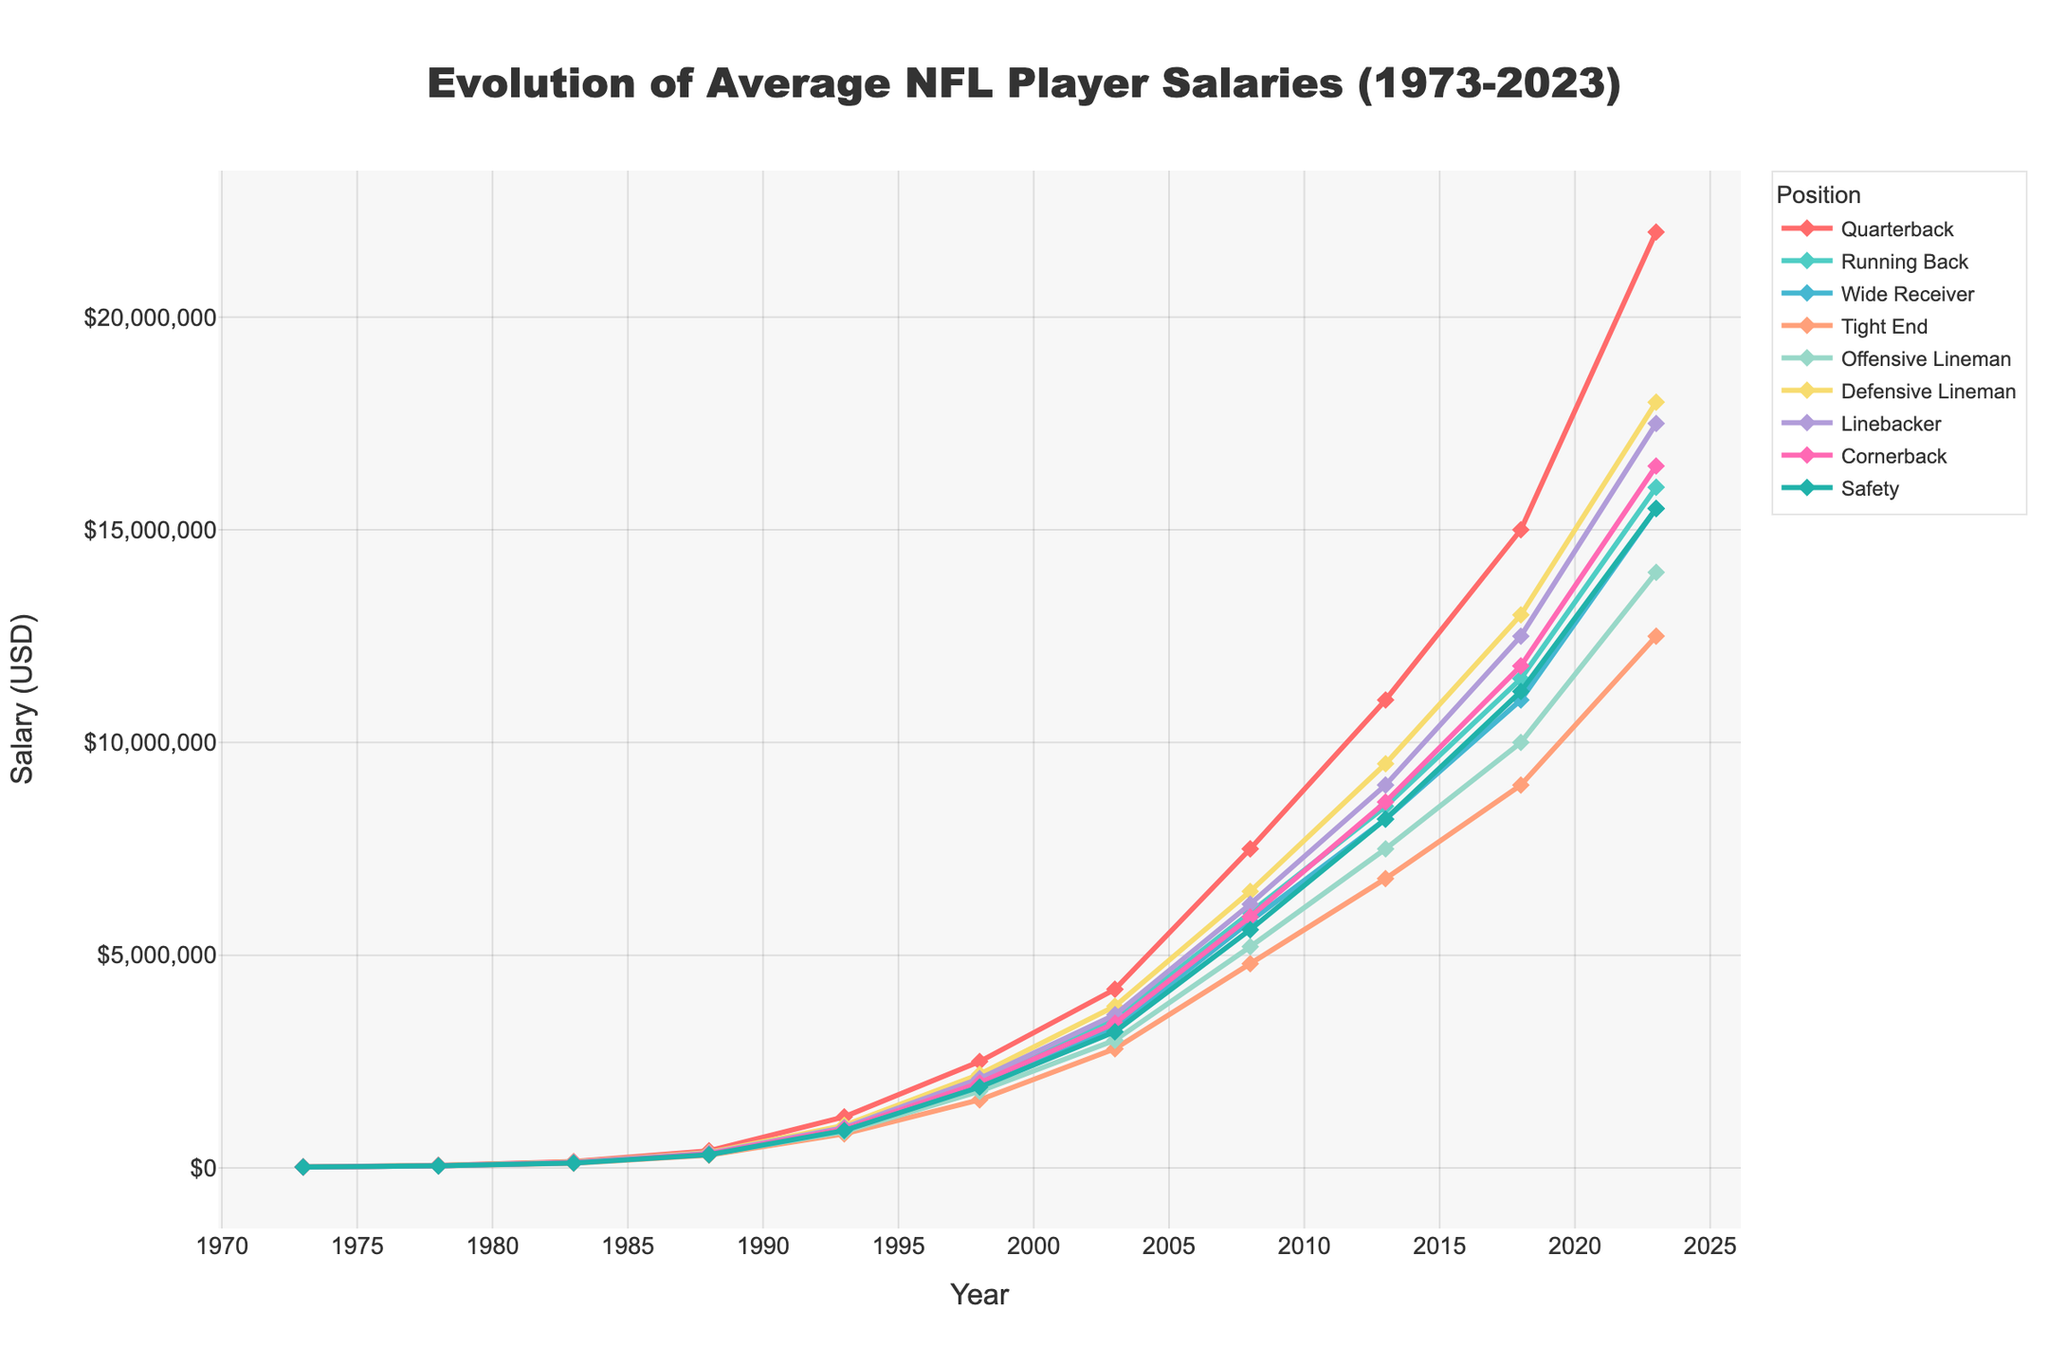Which position had the highest average salary in 2023? To determine this, look at the endpoints of the lines on the far right side of the chart. The line that reaches the highest vertical point represents the highest average salary.
Answer: Quarterback How much did the average salary of a Linebacker increase from 1983 to 2023? Locate the points for Linebackers in 1983 and 2023. Subtract the 1983 salary (128,000) from the 2023 salary (17,500,000).
Answer: 17,372,000 Which position saw the least salary increase over the entire period from 1973 to 2023? Compare the starting and ending points of all the lines. The position with the smallest difference between 1973 and 2023 has the least increase.
Answer: Tight End Among the positions, which one had a higher average salary in 1998: Wide Receiver or Tight End? Check and compare the heights of the points of Wide Receiver and Tight End in 1998.
Answer: Wide Receiver What was the trend in average salaries for Running Backs from 1973 to 2023? Observe the line for Running Backs from left to right. Note how the line rises steadily, indicating a consistent increase over the years.
Answer: Increasing Compare the salaries of Defensive Linemen and Offensive Linemen in 2008. Which one was higher and by how much? Locate the points for both positions in 2008 on the y-axis. Subtract the value for Offensive Linemen (5,200,000) from Defensive Linemen (6,500,000).
Answer: Defensive Linemen by 1,300,000 What is the average salary of a Safety in 1983 and 2003 combined? Add the salaries for Safeties in 1983 (115,000) and 2003 (3,200,000) and divide the sum by 2.
Answer: 1,657,500 Which position had the most significant jump in salary from 1978 to 1983? Compare the slopes of the lines for each position between 1978 and 1983. The steepest slope indicates the most significant jump.
Answer: Quarterback Did any position have a salary decrease at any point during the years shown? Trace the lines carefully from left to right. Look for any sections where a line slopes downward, indicating a decrease.
Answer: No Which position had the closest average salary to 10 million dollars in 2018? Find the points for 2018 and see which line's point is nearest to the 10 million mark on the y-axis.
Answer: Offensive Lineman 